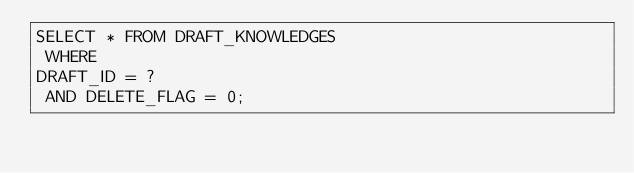Convert code to text. <code><loc_0><loc_0><loc_500><loc_500><_SQL_>SELECT * FROM DRAFT_KNOWLEDGES
 WHERE 
DRAFT_ID = ?
 AND DELETE_FLAG = 0;
</code> 